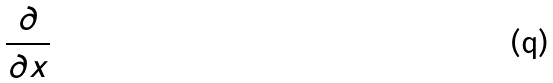Convert formula to latex. <formula><loc_0><loc_0><loc_500><loc_500>\frac { \partial } { \partial x }</formula> 